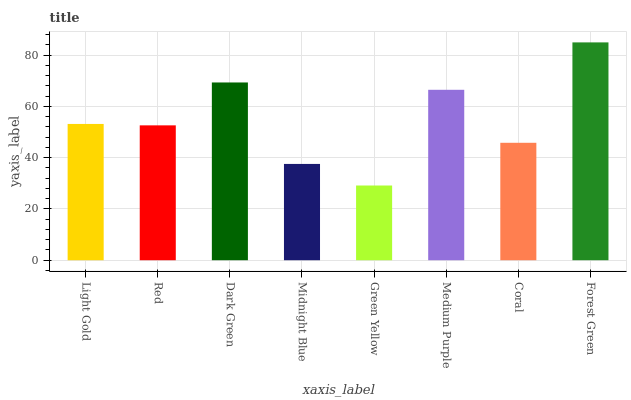Is Green Yellow the minimum?
Answer yes or no. Yes. Is Forest Green the maximum?
Answer yes or no. Yes. Is Red the minimum?
Answer yes or no. No. Is Red the maximum?
Answer yes or no. No. Is Light Gold greater than Red?
Answer yes or no. Yes. Is Red less than Light Gold?
Answer yes or no. Yes. Is Red greater than Light Gold?
Answer yes or no. No. Is Light Gold less than Red?
Answer yes or no. No. Is Light Gold the high median?
Answer yes or no. Yes. Is Red the low median?
Answer yes or no. Yes. Is Green Yellow the high median?
Answer yes or no. No. Is Coral the low median?
Answer yes or no. No. 